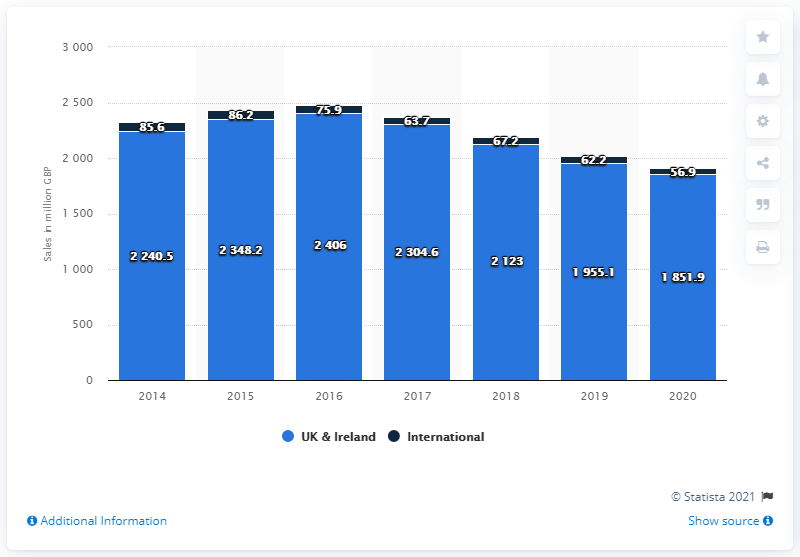How much money did Next plc generate through its UK and Ireland stores in the year ended January 2020?
 1851.9 